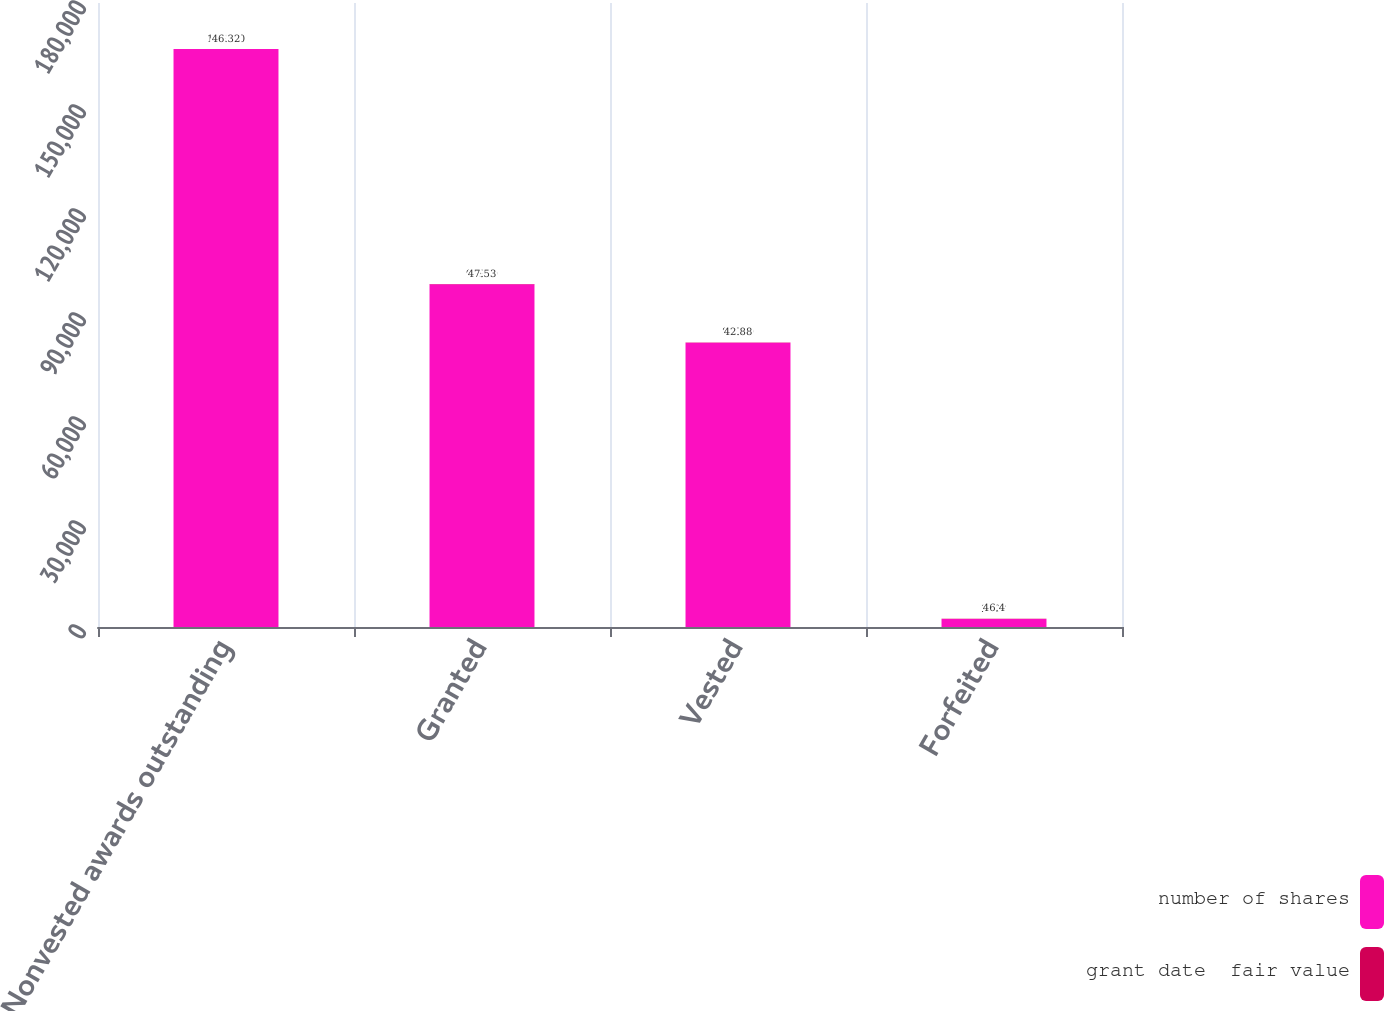Convert chart to OTSL. <chart><loc_0><loc_0><loc_500><loc_500><stacked_bar_chart><ecel><fcel>Nonvested awards outstanding<fcel>Granted<fcel>Vested<fcel>Forfeited<nl><fcel>number of shares<fcel>166700<fcel>98900<fcel>82000<fcel>2300<nl><fcel>grant date  fair value<fcel>46.32<fcel>47.53<fcel>42.88<fcel>46.4<nl></chart> 